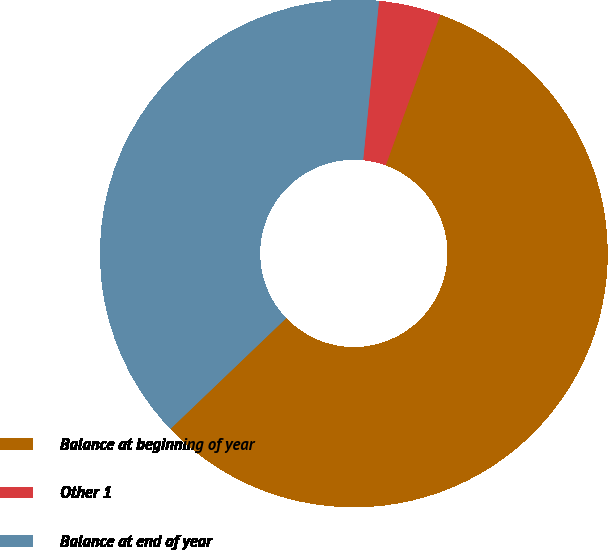Convert chart. <chart><loc_0><loc_0><loc_500><loc_500><pie_chart><fcel>Balance at beginning of year<fcel>Other 1<fcel>Balance at end of year<nl><fcel>57.32%<fcel>3.95%<fcel>38.73%<nl></chart> 